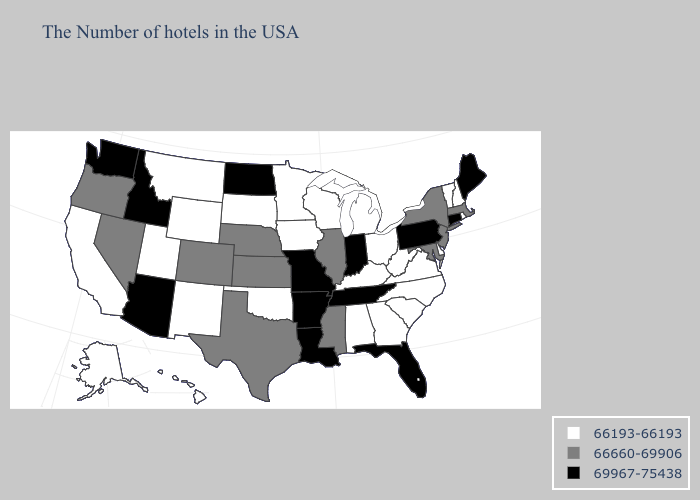Among the states that border Maryland , which have the lowest value?
Keep it brief. Delaware, Virginia, West Virginia. Name the states that have a value in the range 69967-75438?
Concise answer only. Maine, Connecticut, Pennsylvania, Florida, Indiana, Tennessee, Louisiana, Missouri, Arkansas, North Dakota, Arizona, Idaho, Washington. Name the states that have a value in the range 66660-69906?
Concise answer only. Massachusetts, New York, New Jersey, Maryland, Illinois, Mississippi, Kansas, Nebraska, Texas, Colorado, Nevada, Oregon. What is the highest value in the West ?
Keep it brief. 69967-75438. Which states hav the highest value in the MidWest?
Concise answer only. Indiana, Missouri, North Dakota. Does the first symbol in the legend represent the smallest category?
Write a very short answer. Yes. What is the value of West Virginia?
Be succinct. 66193-66193. Does New York have the highest value in the Northeast?
Short answer required. No. Does Oklahoma have the lowest value in the South?
Give a very brief answer. Yes. What is the highest value in states that border Arizona?
Be succinct. 66660-69906. What is the highest value in the West ?
Answer briefly. 69967-75438. Name the states that have a value in the range 66193-66193?
Quick response, please. Rhode Island, New Hampshire, Vermont, Delaware, Virginia, North Carolina, South Carolina, West Virginia, Ohio, Georgia, Michigan, Kentucky, Alabama, Wisconsin, Minnesota, Iowa, Oklahoma, South Dakota, Wyoming, New Mexico, Utah, Montana, California, Alaska, Hawaii. What is the lowest value in the Northeast?
Keep it brief. 66193-66193. Name the states that have a value in the range 69967-75438?
Write a very short answer. Maine, Connecticut, Pennsylvania, Florida, Indiana, Tennessee, Louisiana, Missouri, Arkansas, North Dakota, Arizona, Idaho, Washington. Does Georgia have the same value as Oklahoma?
Write a very short answer. Yes. 